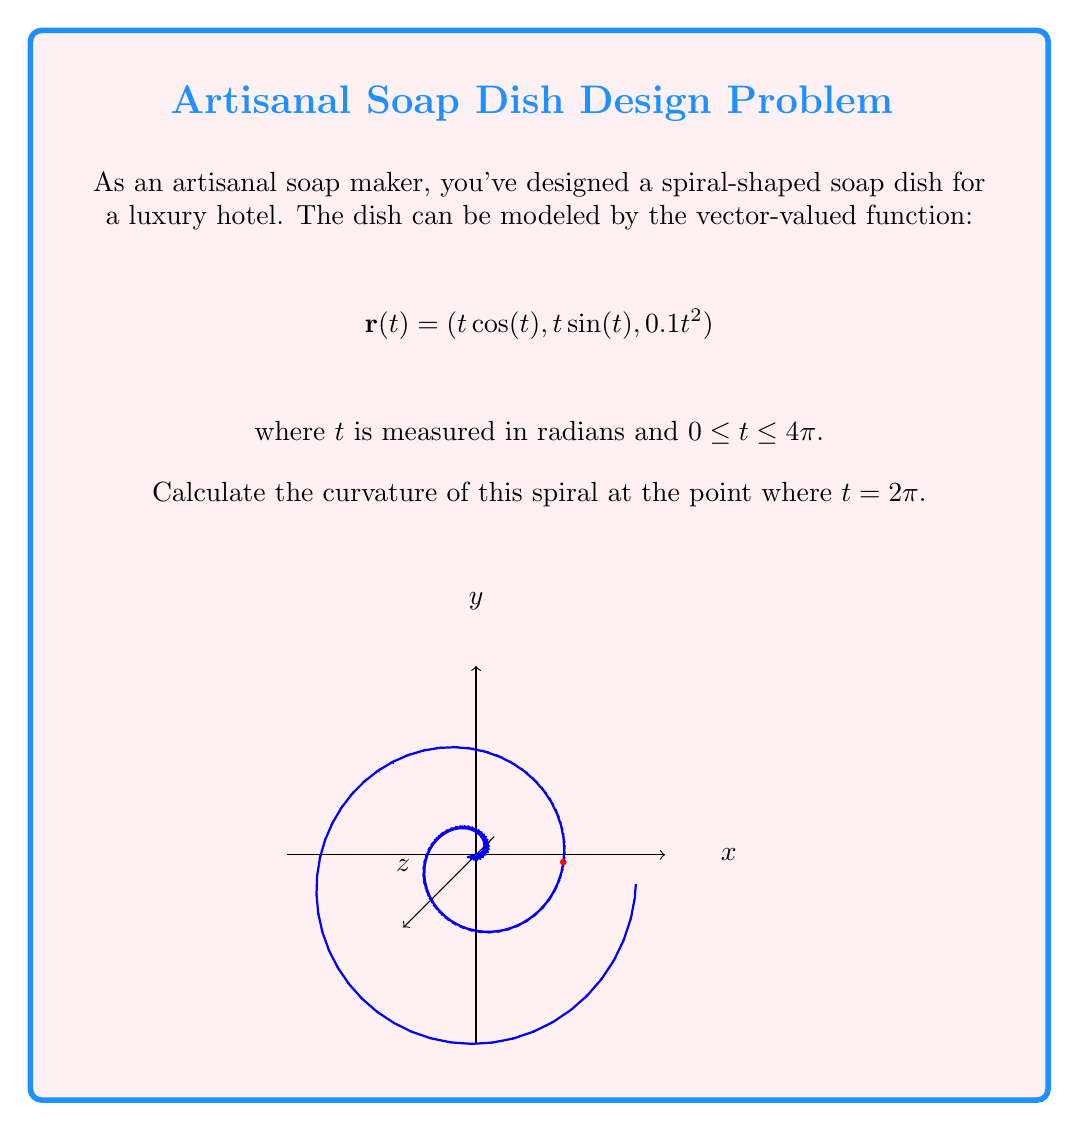Show me your answer to this math problem. To find the curvature of the spiral, we'll follow these steps:

1) First, we need to calculate $\mathbf{r}'(t)$ and $\mathbf{r}''(t)$:

   $$\mathbf{r}'(t) = (\cos(t) - t\sin(t), \sin(t) + t\cos(t), 0.2t)$$
   $$\mathbf{r}''(t) = (-2\sin(t) - t\cos(t), 2\cos(t) - t\sin(t), 0.2)$$

2) The curvature formula is:

   $$\kappa = \frac{|\mathbf{r}'(t) \times \mathbf{r}''(t)|}{|\mathbf{r}'(t)|^3}$$

3) Let's evaluate $\mathbf{r}'(2\pi)$ and $\mathbf{r}''(2\pi)$:

   $$\mathbf{r}'(2\pi) = (1, 2\pi, 0.4\pi)$$
   $$\mathbf{r}''(2\pi) = (-2\pi, 1, 0.2)$$

4) Now, let's calculate the cross product $\mathbf{r}'(2\pi) \times \mathbf{r}''(2\pi)$:

   $$\mathbf{r}'(2\pi) \times \mathbf{r}''(2\pi) = \begin{vmatrix} 
   \mathbf{i} & \mathbf{j} & \mathbf{k} \\
   1 & 2\pi & 0.4\pi \\
   -2\pi & 1 & 0.2
   \end{vmatrix}$$

   $$= (0.4\pi - 0.8\pi^2)\mathbf{i} + (0.2 - 0.4\pi)\mathbf{j} + (2\pi + 4\pi^2)\mathbf{k}$$

5) The magnitude of this cross product is:

   $$|\mathbf{r}'(2\pi) \times \mathbf{r}''(2\pi)| = \sqrt{(0.4\pi - 0.8\pi^2)^2 + (0.2 - 0.4\pi)^2 + (2\pi + 4\pi^2)^2}$$

6) The magnitude of $\mathbf{r}'(2\pi)$ is:

   $$|\mathbf{r}'(2\pi)| = \sqrt{1^2 + (2\pi)^2 + (0.4\pi)^2} = \sqrt{1 + 4\pi^2 + 0.16\pi^2} = \sqrt{1 + 4.16\pi^2}$$

7) Now we can plug these into our curvature formula:

   $$\kappa = \frac{\sqrt{(0.4\pi - 0.8\pi^2)^2 + (0.2 - 0.4\pi)^2 + (2\pi + 4\pi^2)^2}}{(1 + 4.16\pi^2)^{3/2}}$$

This is the curvature of the spiral at $t = 2\pi$.
Answer: $$\kappa = \frac{\sqrt{(0.4\pi - 0.8\pi^2)^2 + (0.2 - 0.4\pi)^2 + (2\pi + 4\pi^2)^2}}{(1 + 4.16\pi^2)^{3/2}}$$ 